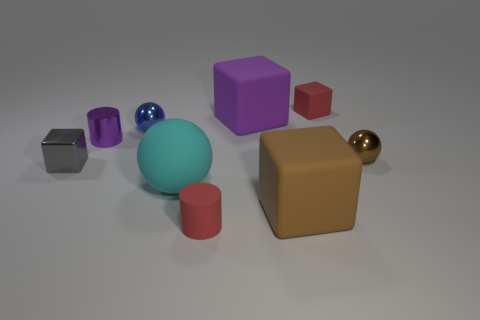Subtract all gray blocks. How many blocks are left? 3 Subtract all large brown matte cubes. How many cubes are left? 3 Add 1 metallic objects. How many objects exist? 10 Subtract all blue blocks. Subtract all cyan spheres. How many blocks are left? 4 Subtract all blocks. How many objects are left? 5 Subtract 1 brown balls. How many objects are left? 8 Subtract all red rubber blocks. Subtract all purple matte things. How many objects are left? 7 Add 6 big cyan rubber objects. How many big cyan rubber objects are left? 7 Add 1 tiny green things. How many tiny green things exist? 1 